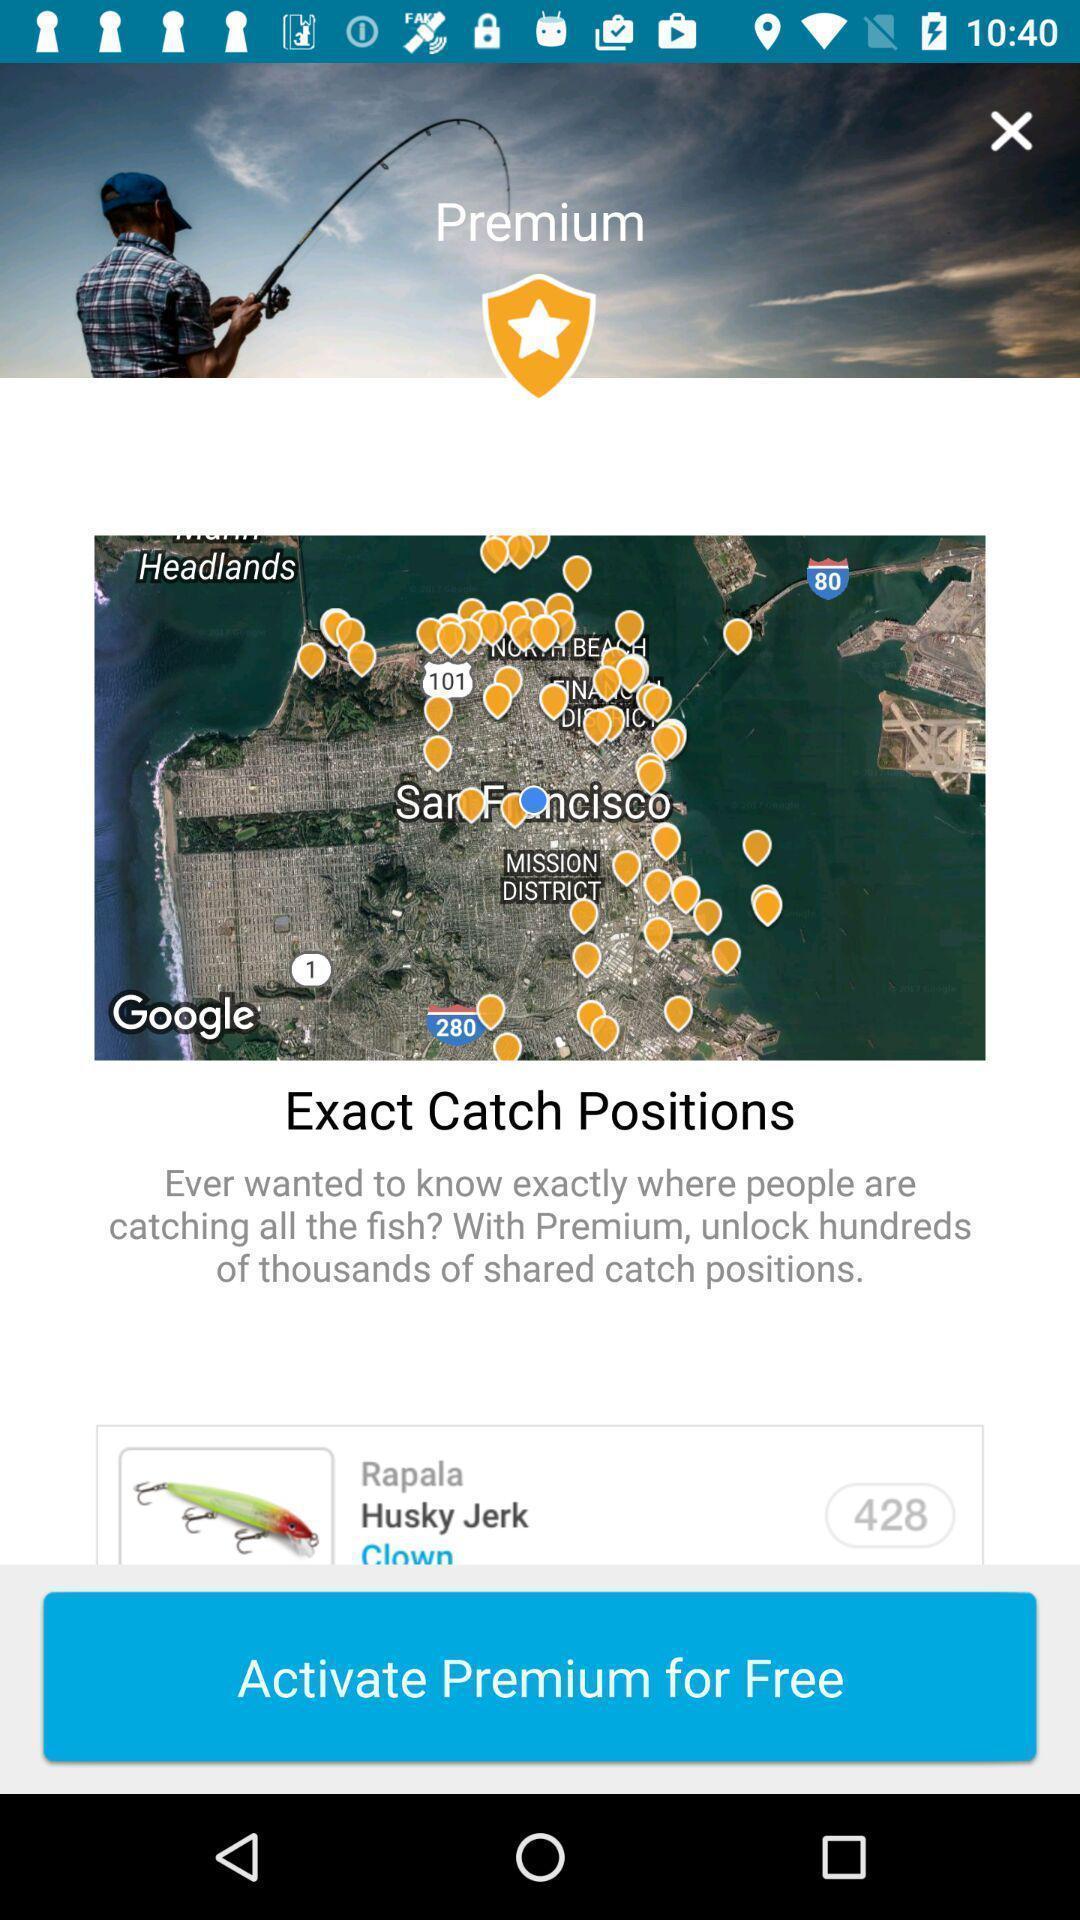Give me a summary of this screen capture. Screen displaying the premium offer notification. 